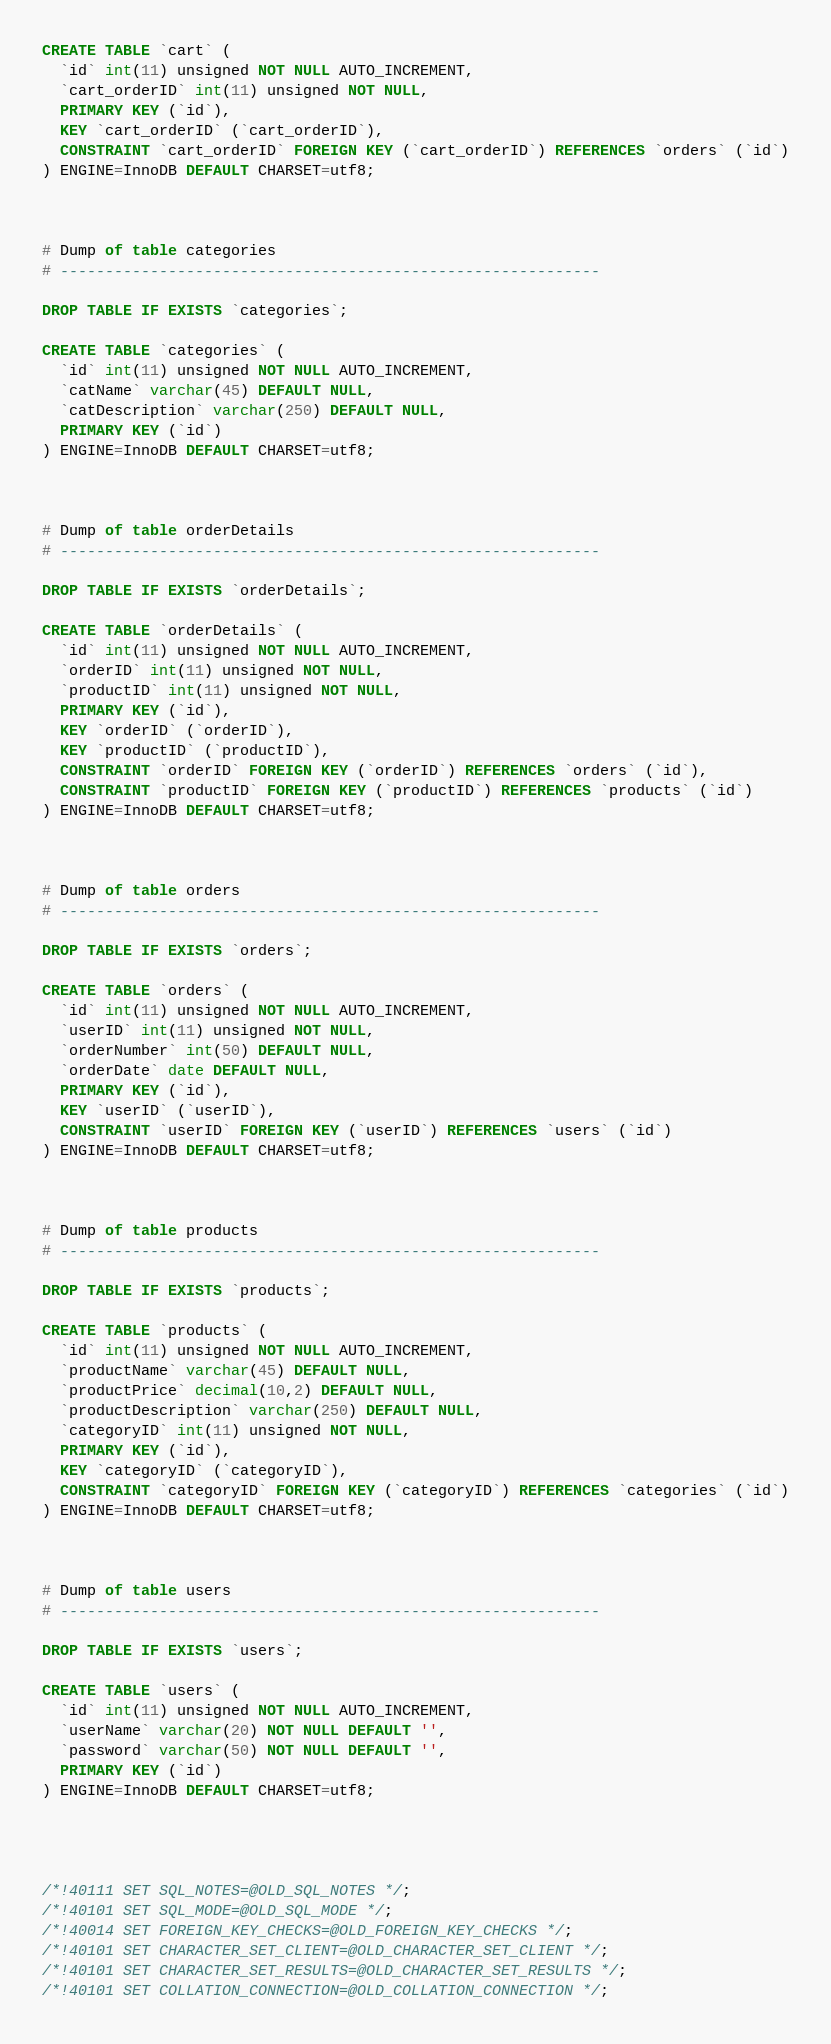Convert code to text. <code><loc_0><loc_0><loc_500><loc_500><_SQL_>
CREATE TABLE `cart` (
  `id` int(11) unsigned NOT NULL AUTO_INCREMENT,
  `cart_orderID` int(11) unsigned NOT NULL,
  PRIMARY KEY (`id`),
  KEY `cart_orderID` (`cart_orderID`),
  CONSTRAINT `cart_orderID` FOREIGN KEY (`cart_orderID`) REFERENCES `orders` (`id`)
) ENGINE=InnoDB DEFAULT CHARSET=utf8;



# Dump of table categories
# ------------------------------------------------------------

DROP TABLE IF EXISTS `categories`;

CREATE TABLE `categories` (
  `id` int(11) unsigned NOT NULL AUTO_INCREMENT,
  `catName` varchar(45) DEFAULT NULL,
  `catDescription` varchar(250) DEFAULT NULL,
  PRIMARY KEY (`id`)
) ENGINE=InnoDB DEFAULT CHARSET=utf8;



# Dump of table orderDetails
# ------------------------------------------------------------

DROP TABLE IF EXISTS `orderDetails`;

CREATE TABLE `orderDetails` (
  `id` int(11) unsigned NOT NULL AUTO_INCREMENT,
  `orderID` int(11) unsigned NOT NULL,
  `productID` int(11) unsigned NOT NULL,
  PRIMARY KEY (`id`),
  KEY `orderID` (`orderID`),
  KEY `productID` (`productID`),
  CONSTRAINT `orderID` FOREIGN KEY (`orderID`) REFERENCES `orders` (`id`),
  CONSTRAINT `productID` FOREIGN KEY (`productID`) REFERENCES `products` (`id`)
) ENGINE=InnoDB DEFAULT CHARSET=utf8;



# Dump of table orders
# ------------------------------------------------------------

DROP TABLE IF EXISTS `orders`;

CREATE TABLE `orders` (
  `id` int(11) unsigned NOT NULL AUTO_INCREMENT,
  `userID` int(11) unsigned NOT NULL,
  `orderNumber` int(50) DEFAULT NULL,
  `orderDate` date DEFAULT NULL,
  PRIMARY KEY (`id`),
  KEY `userID` (`userID`),
  CONSTRAINT `userID` FOREIGN KEY (`userID`) REFERENCES `users` (`id`)
) ENGINE=InnoDB DEFAULT CHARSET=utf8;



# Dump of table products
# ------------------------------------------------------------

DROP TABLE IF EXISTS `products`;

CREATE TABLE `products` (
  `id` int(11) unsigned NOT NULL AUTO_INCREMENT,
  `productName` varchar(45) DEFAULT NULL,
  `productPrice` decimal(10,2) DEFAULT NULL,
  `productDescription` varchar(250) DEFAULT NULL,
  `categoryID` int(11) unsigned NOT NULL,
  PRIMARY KEY (`id`),
  KEY `categoryID` (`categoryID`),
  CONSTRAINT `categoryID` FOREIGN KEY (`categoryID`) REFERENCES `categories` (`id`)
) ENGINE=InnoDB DEFAULT CHARSET=utf8;



# Dump of table users
# ------------------------------------------------------------

DROP TABLE IF EXISTS `users`;

CREATE TABLE `users` (
  `id` int(11) unsigned NOT NULL AUTO_INCREMENT,
  `userName` varchar(20) NOT NULL DEFAULT '',
  `password` varchar(50) NOT NULL DEFAULT '',
  PRIMARY KEY (`id`)
) ENGINE=InnoDB DEFAULT CHARSET=utf8;




/*!40111 SET SQL_NOTES=@OLD_SQL_NOTES */;
/*!40101 SET SQL_MODE=@OLD_SQL_MODE */;
/*!40014 SET FOREIGN_KEY_CHECKS=@OLD_FOREIGN_KEY_CHECKS */;
/*!40101 SET CHARACTER_SET_CLIENT=@OLD_CHARACTER_SET_CLIENT */;
/*!40101 SET CHARACTER_SET_RESULTS=@OLD_CHARACTER_SET_RESULTS */;
/*!40101 SET COLLATION_CONNECTION=@OLD_COLLATION_CONNECTION */;
</code> 